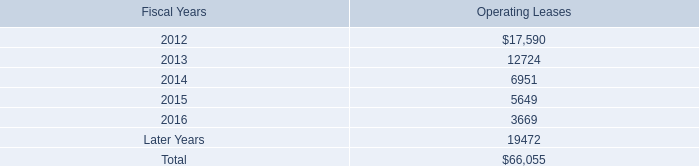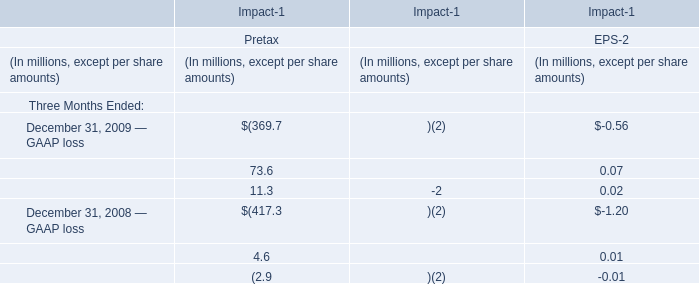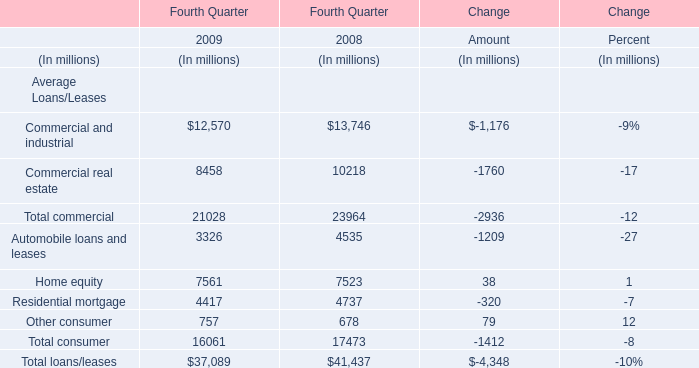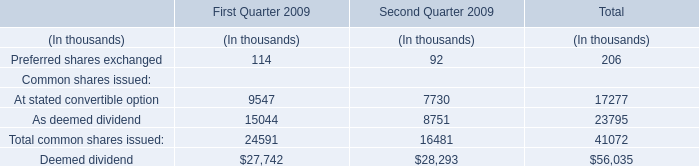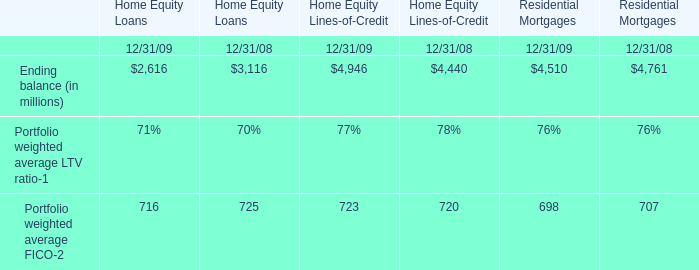What is the total amount of the Residential mortgage, the Automobile loans and leases, the Commercial real estate and the Home equity in the Fourth Quarter of 2008? (in million) 
Computations: (((4737 + 4535) + 10218) + 7523)
Answer: 27013.0. 